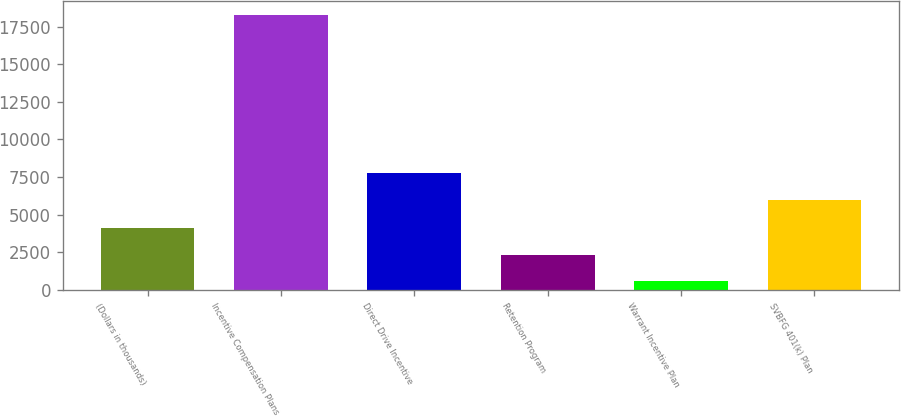<chart> <loc_0><loc_0><loc_500><loc_500><bar_chart><fcel>(Dollars in thousands)<fcel>Incentive Compensation Plans<fcel>Direct Drive Incentive<fcel>Retention Program<fcel>Warrant Incentive Plan<fcel>SVBFG 401(k) Plan<nl><fcel>4119.4<fcel>18285<fcel>7780.7<fcel>2348.7<fcel>578<fcel>6010<nl></chart> 